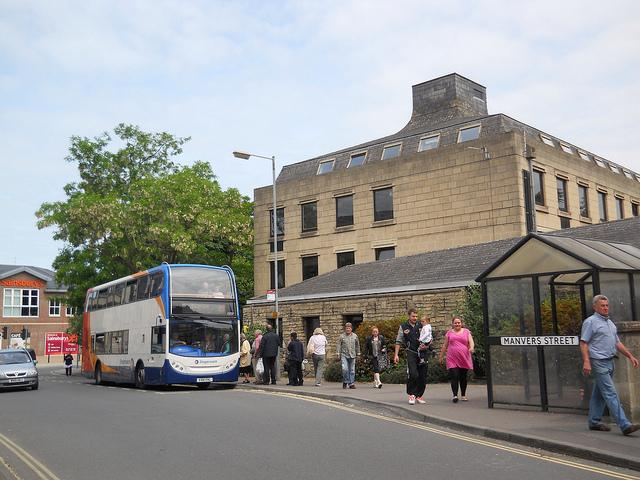When was the first bus stop installed? Please explain your reasoning. 1820s. None of these dates seem likely because automobiles were not invented yet but this date is closest to the date for sure. 